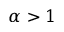<formula> <loc_0><loc_0><loc_500><loc_500>\alpha > 1</formula> 